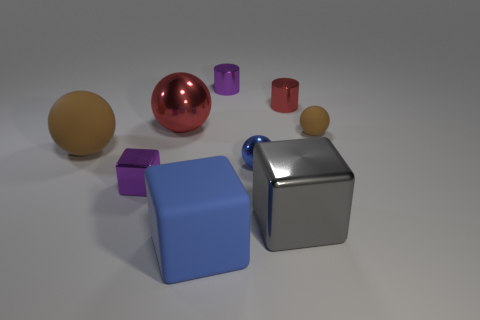Is the color of the big matte cube the same as the small shiny ball?
Provide a succinct answer. Yes. What shape is the matte object that is behind the gray block and left of the tiny red metallic cylinder?
Provide a succinct answer. Sphere. Is the number of tiny purple metal cylinders on the left side of the small blue thing greater than the number of tiny yellow things?
Offer a terse response. Yes. There is a gray block that is made of the same material as the large red ball; what size is it?
Ensure brevity in your answer.  Large. What number of small rubber things are the same color as the large rubber ball?
Make the answer very short. 1. There is a rubber ball in front of the tiny brown object; is it the same color as the tiny rubber object?
Provide a succinct answer. Yes. Are there an equal number of purple cylinders that are in front of the blue sphere and big brown rubber objects behind the large red metal ball?
Keep it short and to the point. Yes. What color is the small sphere behind the large brown ball?
Offer a very short reply. Brown. Is the number of big gray metal cubes on the left side of the gray metallic object the same as the number of brown shiny objects?
Give a very brief answer. Yes. What number of other things are the same shape as the tiny brown thing?
Ensure brevity in your answer.  3. 